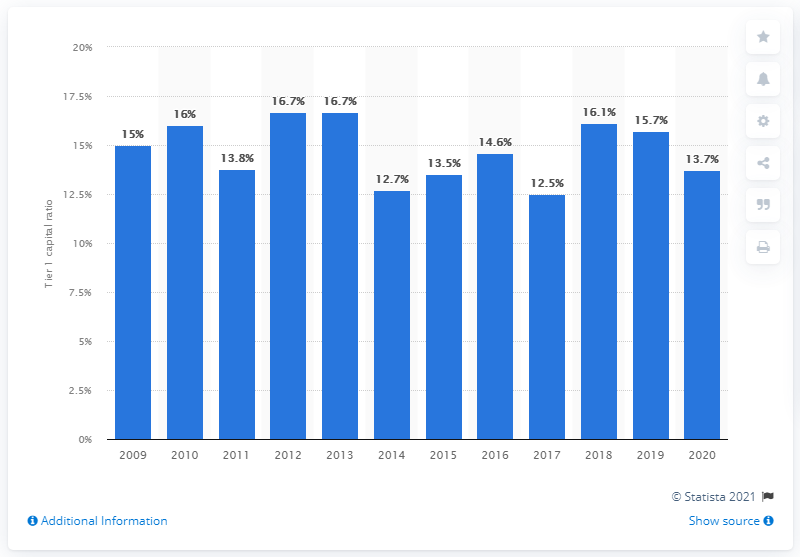List a handful of essential elements in this visual. The tier 1 capital ratio at Goldman Sachs in 2020 was 13.7. 